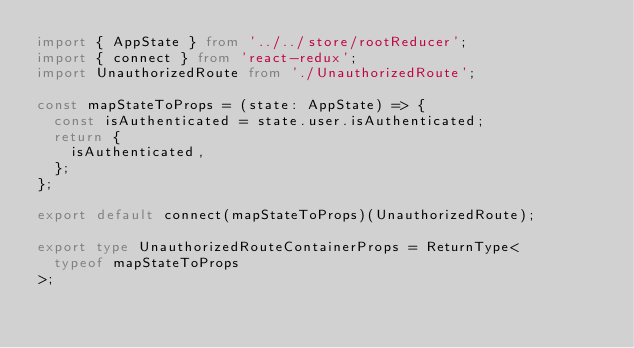Convert code to text. <code><loc_0><loc_0><loc_500><loc_500><_TypeScript_>import { AppState } from '../../store/rootReducer';
import { connect } from 'react-redux';
import UnauthorizedRoute from './UnauthorizedRoute';

const mapStateToProps = (state: AppState) => {
  const isAuthenticated = state.user.isAuthenticated;
  return {
    isAuthenticated,
  };
};

export default connect(mapStateToProps)(UnauthorizedRoute);

export type UnauthorizedRouteContainerProps = ReturnType<
  typeof mapStateToProps
>;
</code> 